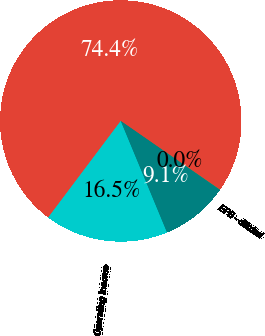Convert chart to OTSL. <chart><loc_0><loc_0><loc_500><loc_500><pie_chart><fcel>Net revenues<fcel>Operating income<fcel>Net earnings attributable to<fcel>EPS - diluted<nl><fcel>74.38%<fcel>16.52%<fcel>9.09%<fcel>0.01%<nl></chart> 